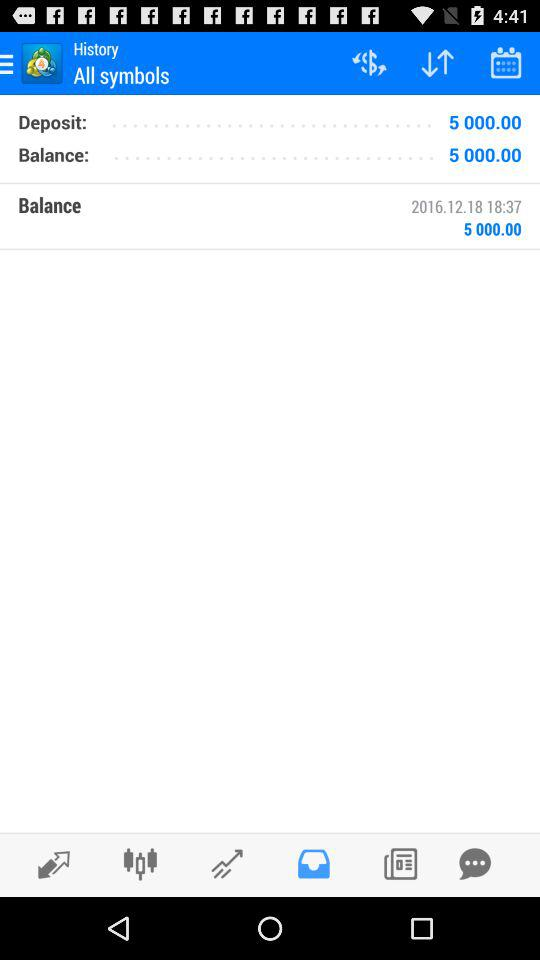How much is the balance on 2016.12.18? The balance is "5000.00". 